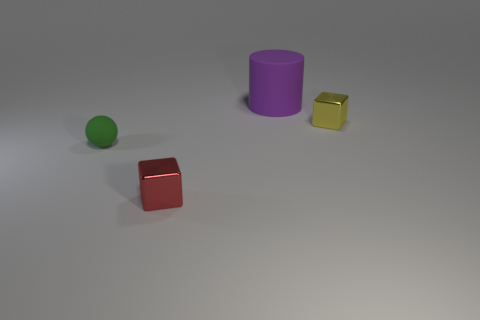There is a large object that is the same material as the green ball; what is its color?
Offer a very short reply. Purple. Is the number of tiny shiny objects greater than the number of tiny yellow blocks?
Your answer should be compact. Yes. Do the purple thing and the yellow object have the same material?
Ensure brevity in your answer.  No. There is a tiny green object that is the same material as the purple thing; what shape is it?
Your answer should be compact. Sphere. Are there fewer tiny balls than small red cylinders?
Your response must be concise. No. There is a thing that is on the right side of the tiny red cube and in front of the big purple rubber object; what is its material?
Make the answer very short. Metal. What is the size of the rubber thing behind the cube to the right of the large purple rubber object that is behind the tiny red shiny object?
Make the answer very short. Large. There is a red thing; is its shape the same as the matte object in front of the big matte cylinder?
Provide a succinct answer. No. How many matte objects are in front of the purple cylinder and behind the green object?
Offer a very short reply. 0. What number of brown things are either shiny blocks or tiny cylinders?
Ensure brevity in your answer.  0. 